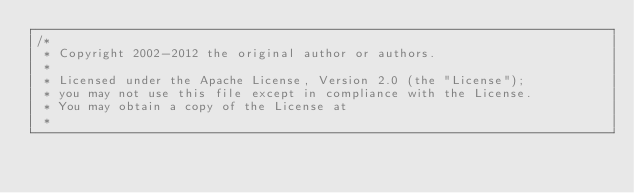Convert code to text. <code><loc_0><loc_0><loc_500><loc_500><_Java_>/*
 * Copyright 2002-2012 the original author or authors.
 *
 * Licensed under the Apache License, Version 2.0 (the "License");
 * you may not use this file except in compliance with the License.
 * You may obtain a copy of the License at
 *</code> 